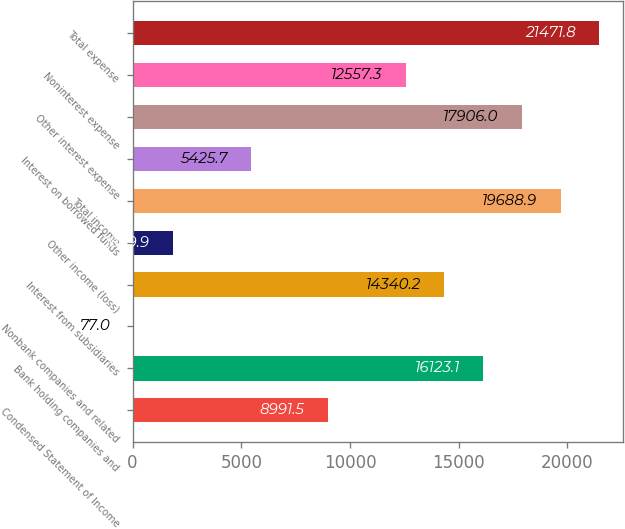Convert chart. <chart><loc_0><loc_0><loc_500><loc_500><bar_chart><fcel>Condensed Statement of Income<fcel>Bank holding companies and<fcel>Nonbank companies and related<fcel>Interest from subsidiaries<fcel>Other income (loss)<fcel>Total income<fcel>Interest on borrowed funds<fcel>Other interest expense<fcel>Noninterest expense<fcel>Total expense<nl><fcel>8991.5<fcel>16123.1<fcel>77<fcel>14340.2<fcel>1859.9<fcel>19688.9<fcel>5425.7<fcel>17906<fcel>12557.3<fcel>21471.8<nl></chart> 